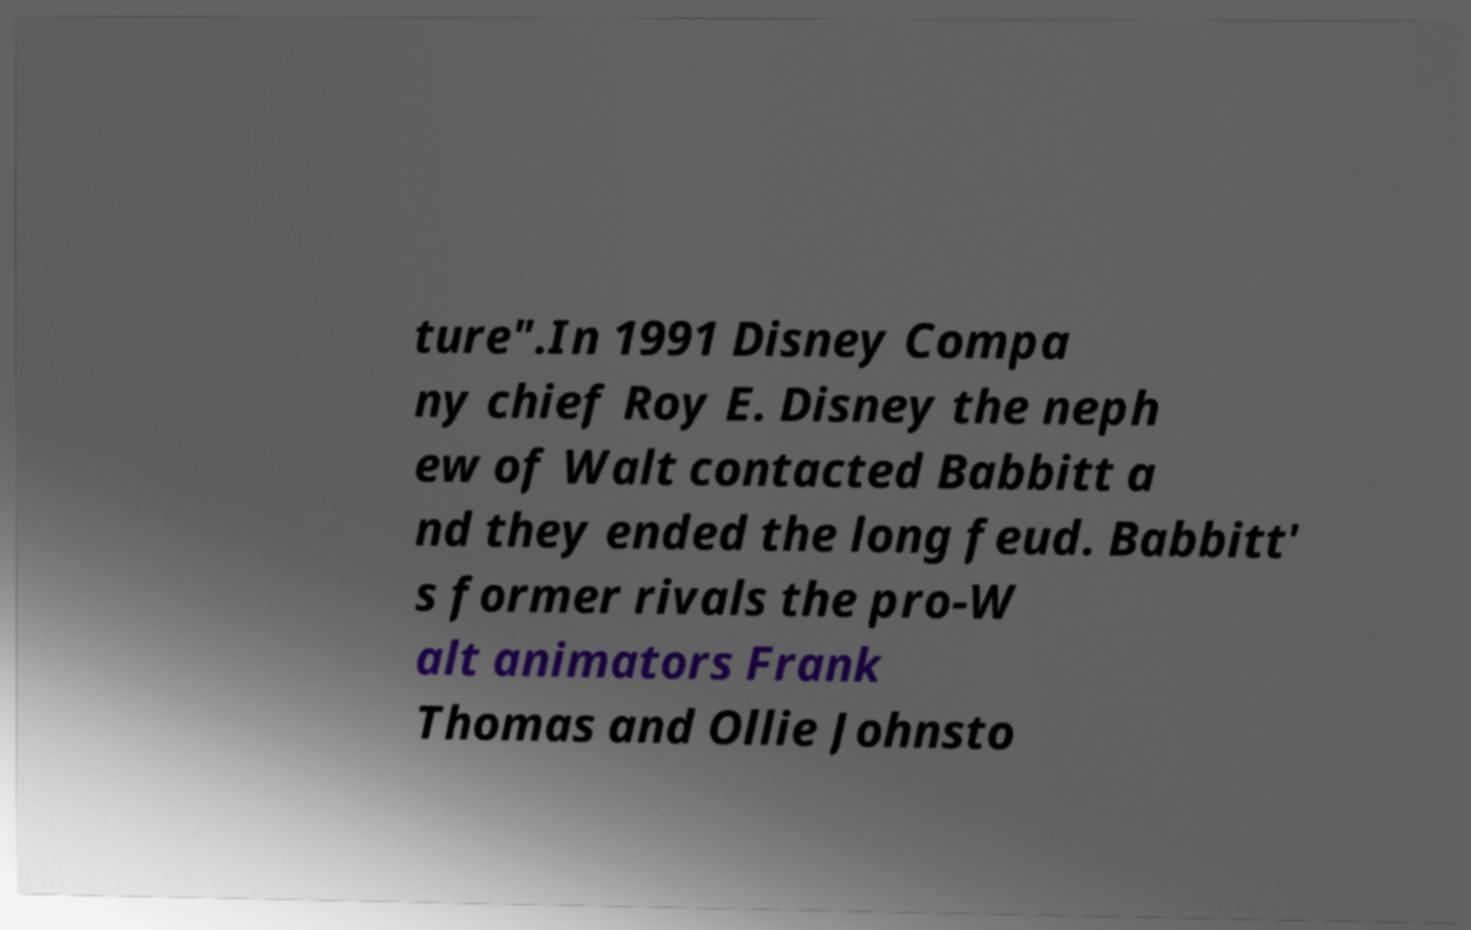Could you assist in decoding the text presented in this image and type it out clearly? ture".In 1991 Disney Compa ny chief Roy E. Disney the neph ew of Walt contacted Babbitt a nd they ended the long feud. Babbitt' s former rivals the pro-W alt animators Frank Thomas and Ollie Johnsto 